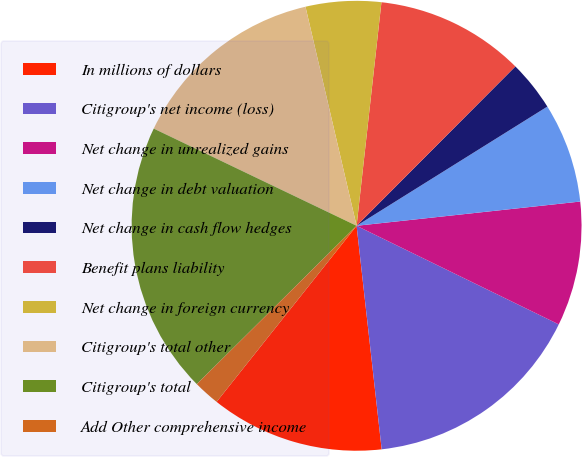Convert chart. <chart><loc_0><loc_0><loc_500><loc_500><pie_chart><fcel>In millions of dollars<fcel>Citigroup's net income (loss)<fcel>Net change in unrealized gains<fcel>Net change in debt valuation<fcel>Net change in cash flow hedges<fcel>Benefit plans liability<fcel>Net change in foreign currency<fcel>Citigroup's total other<fcel>Citigroup's total<fcel>Add Other comprehensive income<nl><fcel>12.47%<fcel>16.0%<fcel>8.94%<fcel>7.17%<fcel>3.64%<fcel>10.71%<fcel>5.41%<fcel>14.24%<fcel>19.54%<fcel>1.88%<nl></chart> 